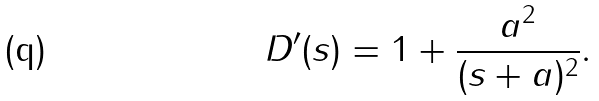<formula> <loc_0><loc_0><loc_500><loc_500>D ^ { \prime } ( s ) = 1 + \frac { a ^ { 2 } } { ( s + a ) ^ { 2 } } .</formula> 